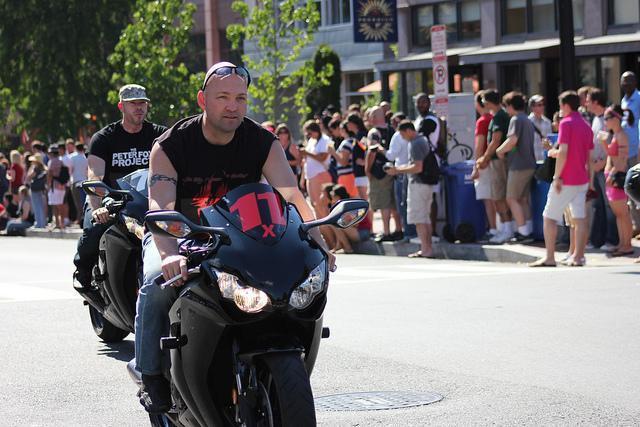How many motorcycles can be seen?
Give a very brief answer. 2. How many people are there?
Give a very brief answer. 10. 